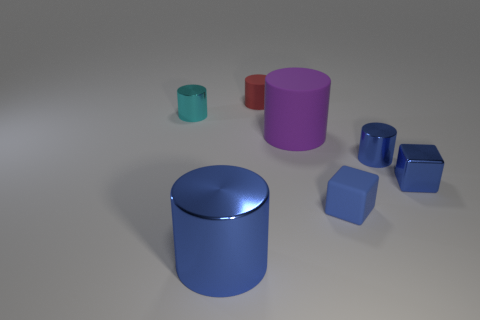Subtract 2 cylinders. How many cylinders are left? 3 Subtract all red cylinders. How many cylinders are left? 4 Subtract all large rubber cylinders. How many cylinders are left? 4 Subtract all red cylinders. Subtract all purple spheres. How many cylinders are left? 4 Add 3 small cylinders. How many objects exist? 10 Subtract all cylinders. How many objects are left? 2 Add 2 metallic blocks. How many metallic blocks exist? 3 Subtract 0 red cubes. How many objects are left? 7 Subtract all red matte blocks. Subtract all cyan objects. How many objects are left? 6 Add 5 tiny blue metallic cylinders. How many tiny blue metallic cylinders are left? 6 